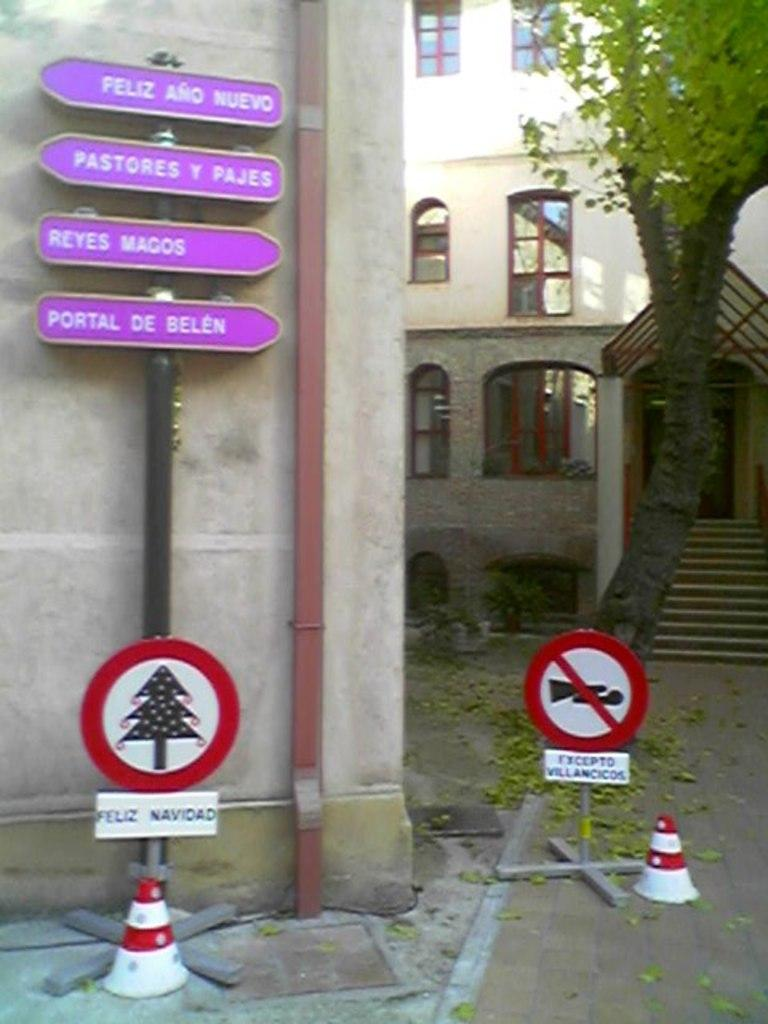<image>
Give a short and clear explanation of the subsequent image. A street sign in purple has the words Portal De Belen on it. 